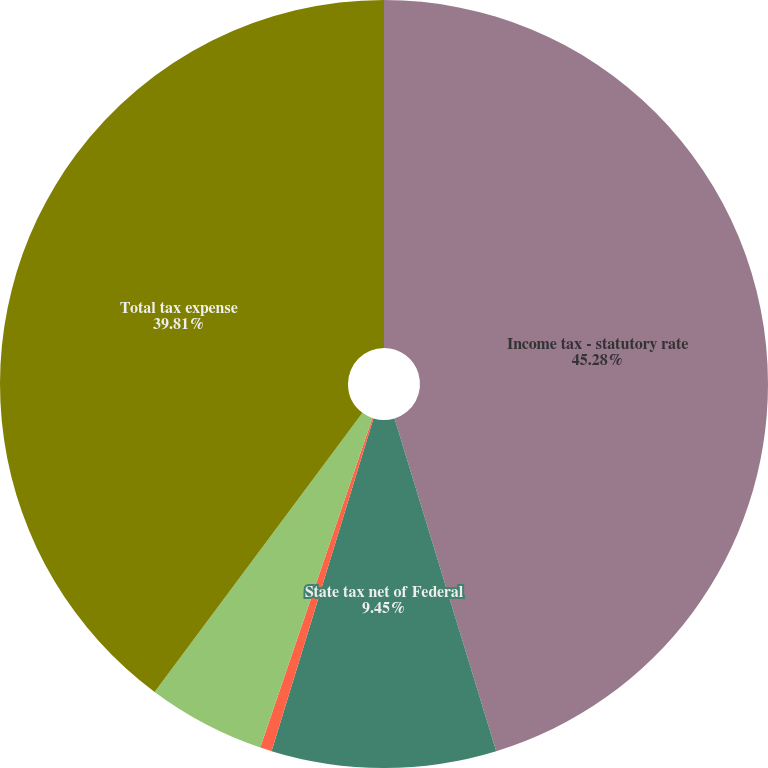Convert chart to OTSL. <chart><loc_0><loc_0><loc_500><loc_500><pie_chart><fcel>Income tax - statutory rate<fcel>State tax net of Federal<fcel>Non-deductible meals and<fcel>Other net<fcel>Total tax expense<nl><fcel>45.28%<fcel>9.45%<fcel>0.49%<fcel>4.97%<fcel>39.81%<nl></chart> 